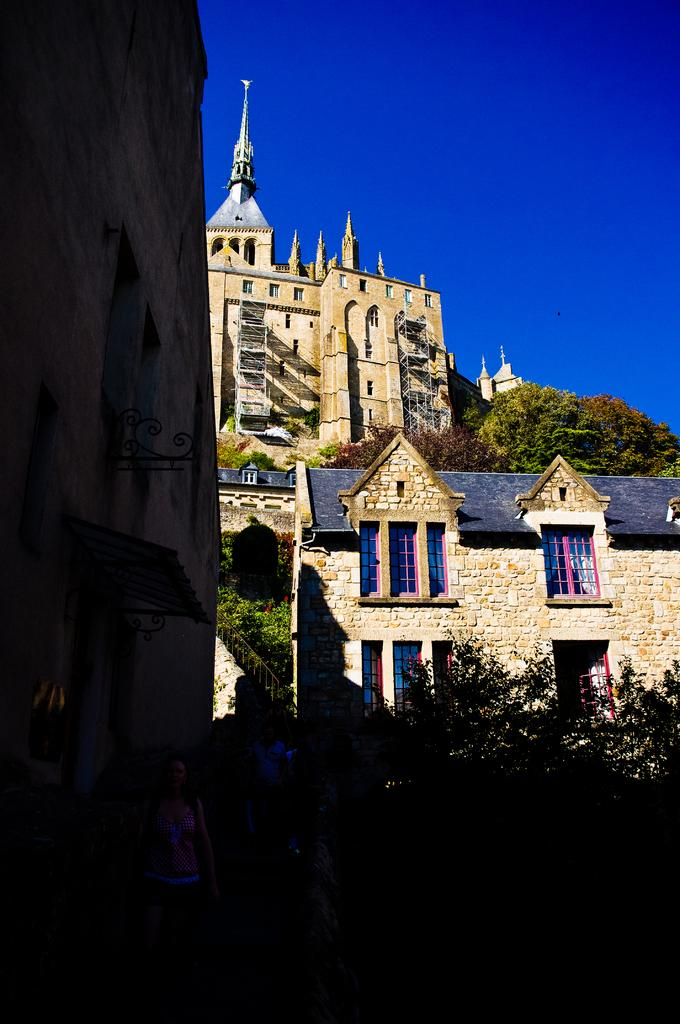What type of structures can be seen in the image? There are buildings in the image. What other natural elements are present in the image? There are trees in the image. What color is the sky in the image? The sky is blue at the top of the image. Reasoning: Let' Let's think step by step in order to produce the conversation. We start by identifying the main subjects in the image, which are the buildings and trees. Then, we describe the sky's color, which is blue. Each question is designed to elicit a specific detail about the image that is known from the provided facts. Absurd Question/Answer: Is there a partner holding an umbrella in the image? There is no partner or umbrella present in the image. What is the image trying to draw attention to? The image does not have a specific subject or focus that is trying to draw attention to something. Is there a partner holding an umbrella in the image? There is no partner or umbrella present in the image. What is the image trying to draw attention to? The image does not have a specific subject or focus that is trying to draw attention to something. 